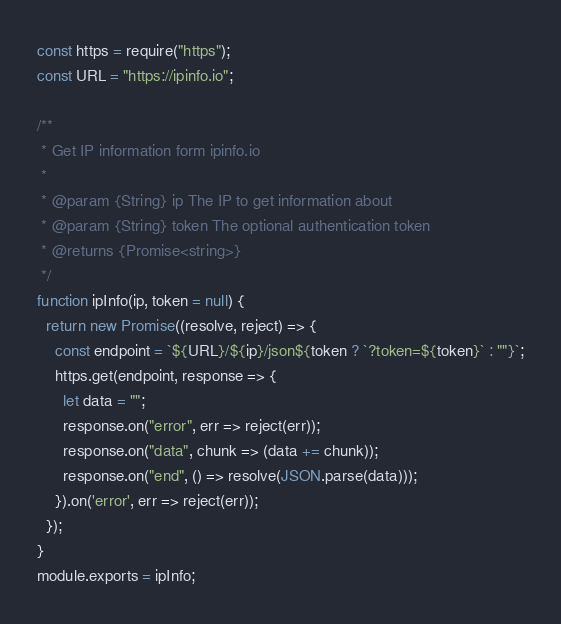Convert code to text. <code><loc_0><loc_0><loc_500><loc_500><_JavaScript_>const https = require("https");
const URL = "https://ipinfo.io";

/**
 * Get IP information form ipinfo.io
 *
 * @param {String} ip The IP to get information about
 * @param {String} token The optional authentication token
 * @returns {Promise<string>}
 */
function ipInfo(ip, token = null) {
  return new Promise((resolve, reject) => {
    const endpoint = `${URL}/${ip}/json${token ? `?token=${token}` : ""}`;
    https.get(endpoint, response => {
      let data = "";
      response.on("error", err => reject(err));
      response.on("data", chunk => (data += chunk));
      response.on("end", () => resolve(JSON.parse(data)));
    }).on('error', err => reject(err));
  });
}
module.exports = ipInfo;
</code> 